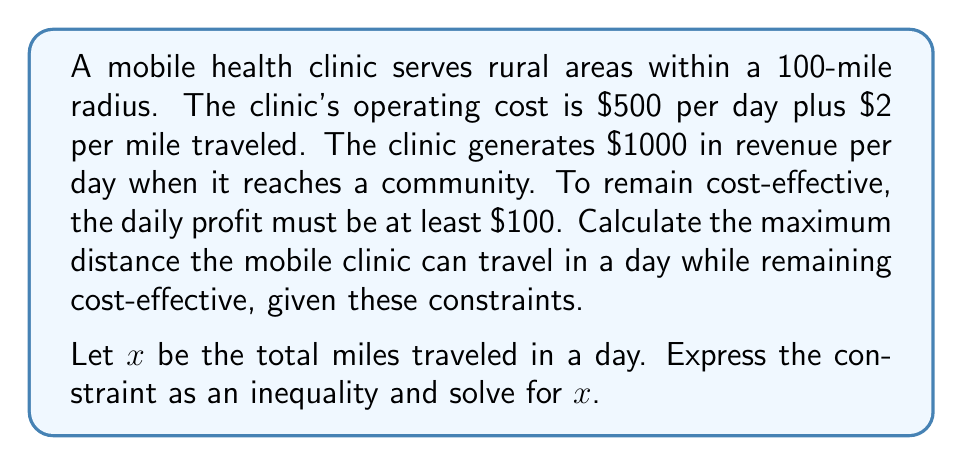Solve this math problem. Let's approach this step-by-step:

1) First, let's define our variables:
   $x$ = total miles traveled in a day
   
2) Now, let's express the daily profit in terms of $x$:
   Profit = Revenue - Costs
   Profit = $1000 - ($500 + $2x)$
   
3) We know that for the clinic to remain cost-effective, the profit must be at least $100:
   $1000 - (500 + 2x) \geq 100$

4) Let's solve this inequality:
   $1000 - 500 - 2x \geq 100$
   $500 - 2x \geq 100$
   $-2x \geq -400$
   $2x \leq 400$
   $x \leq 200$

5) However, we also know that the clinic can only travel within a 100-mile radius. This means the total distance traveled (round trip) cannot exceed 200 miles.

6) Therefore, the maximum distance the clinic can travel while remaining cost-effective is the smaller of these two values: 200 miles (from the inequality) and 200 miles (from the radius constraint).
Answer: The maximum distance the mobile health clinic can travel in a day while remaining cost-effective is 200 miles. 